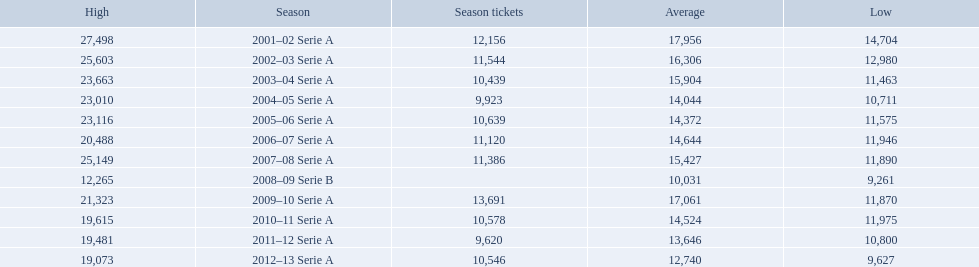What seasons were played at the stadio ennio tardini 2001–02 Serie A, 2002–03 Serie A, 2003–04 Serie A, 2004–05 Serie A, 2005–06 Serie A, 2006–07 Serie A, 2007–08 Serie A, 2008–09 Serie B, 2009–10 Serie A, 2010–11 Serie A, 2011–12 Serie A, 2012–13 Serie A. Which of these seasons had season tickets? 2001–02 Serie A, 2002–03 Serie A, 2003–04 Serie A, 2004–05 Serie A, 2005–06 Serie A, 2006–07 Serie A, 2007–08 Serie A, 2009–10 Serie A, 2010–11 Serie A, 2011–12 Serie A, 2012–13 Serie A. How many season tickets did the 2007-08 season have? 11,386. Could you parse the entire table? {'header': ['High', 'Season', 'Season tickets', 'Average', 'Low'], 'rows': [['27,498', '2001–02 Serie A', '12,156', '17,956', '14,704'], ['25,603', '2002–03 Serie A', '11,544', '16,306', '12,980'], ['23,663', '2003–04 Serie A', '10,439', '15,904', '11,463'], ['23,010', '2004–05 Serie A', '9,923', '14,044', '10,711'], ['23,116', '2005–06 Serie A', '10,639', '14,372', '11,575'], ['20,488', '2006–07 Serie A', '11,120', '14,644', '11,946'], ['25,149', '2007–08 Serie A', '11,386', '15,427', '11,890'], ['12,265', '2008–09 Serie B', '', '10,031', '9,261'], ['21,323', '2009–10 Serie A', '13,691', '17,061', '11,870'], ['19,615', '2010–11 Serie A', '10,578', '14,524', '11,975'], ['19,481', '2011–12 Serie A', '9,620', '13,646', '10,800'], ['19,073', '2012–13 Serie A', '10,546', '12,740', '9,627']]} 